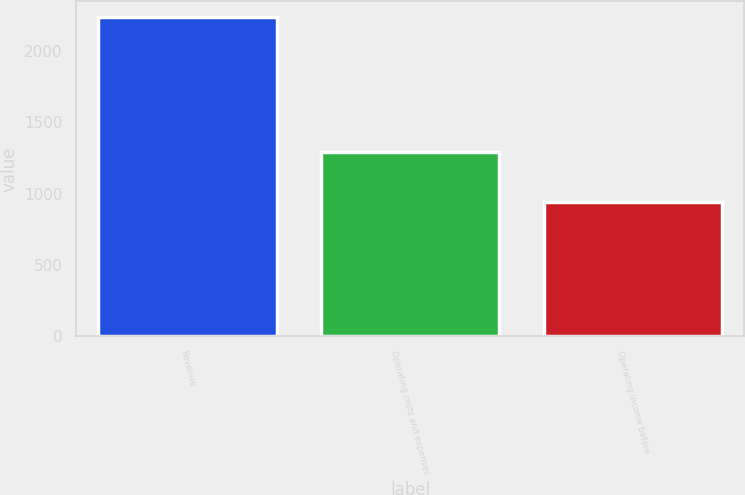Convert chart. <chart><loc_0><loc_0><loc_500><loc_500><bar_chart><fcel>Revenue<fcel>Operating costs and expenses<fcel>Operating income before<nl><fcel>2235<fcel>1292<fcel>943<nl></chart> 